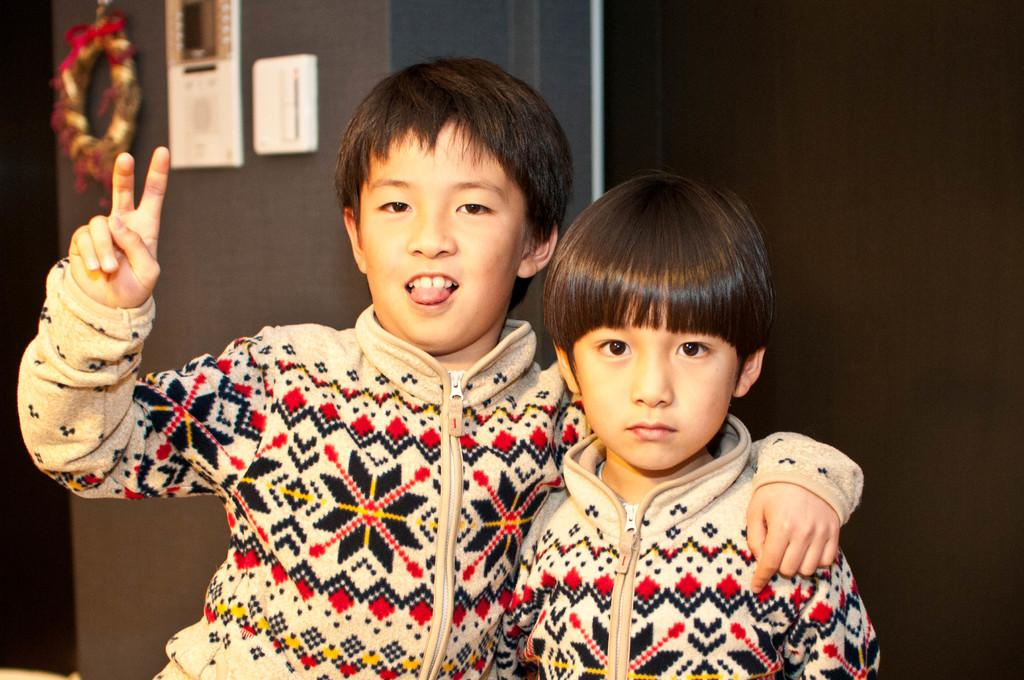How many boys are in the image? There are two boys in the image. What are the boys wearing that is similar? The boys are wearing the same jackets. What are the boys doing in the image? The boys are posing for the picture. What can be seen in the background of the image? There is a wall in the background of the image, and objects are attached to the wall. What type of butter is being used by the minister in the image? There is no minister or butter present in the image. What time of day is it in the image, based on the hour? The image does not provide information about the time of day or any specific hour. 